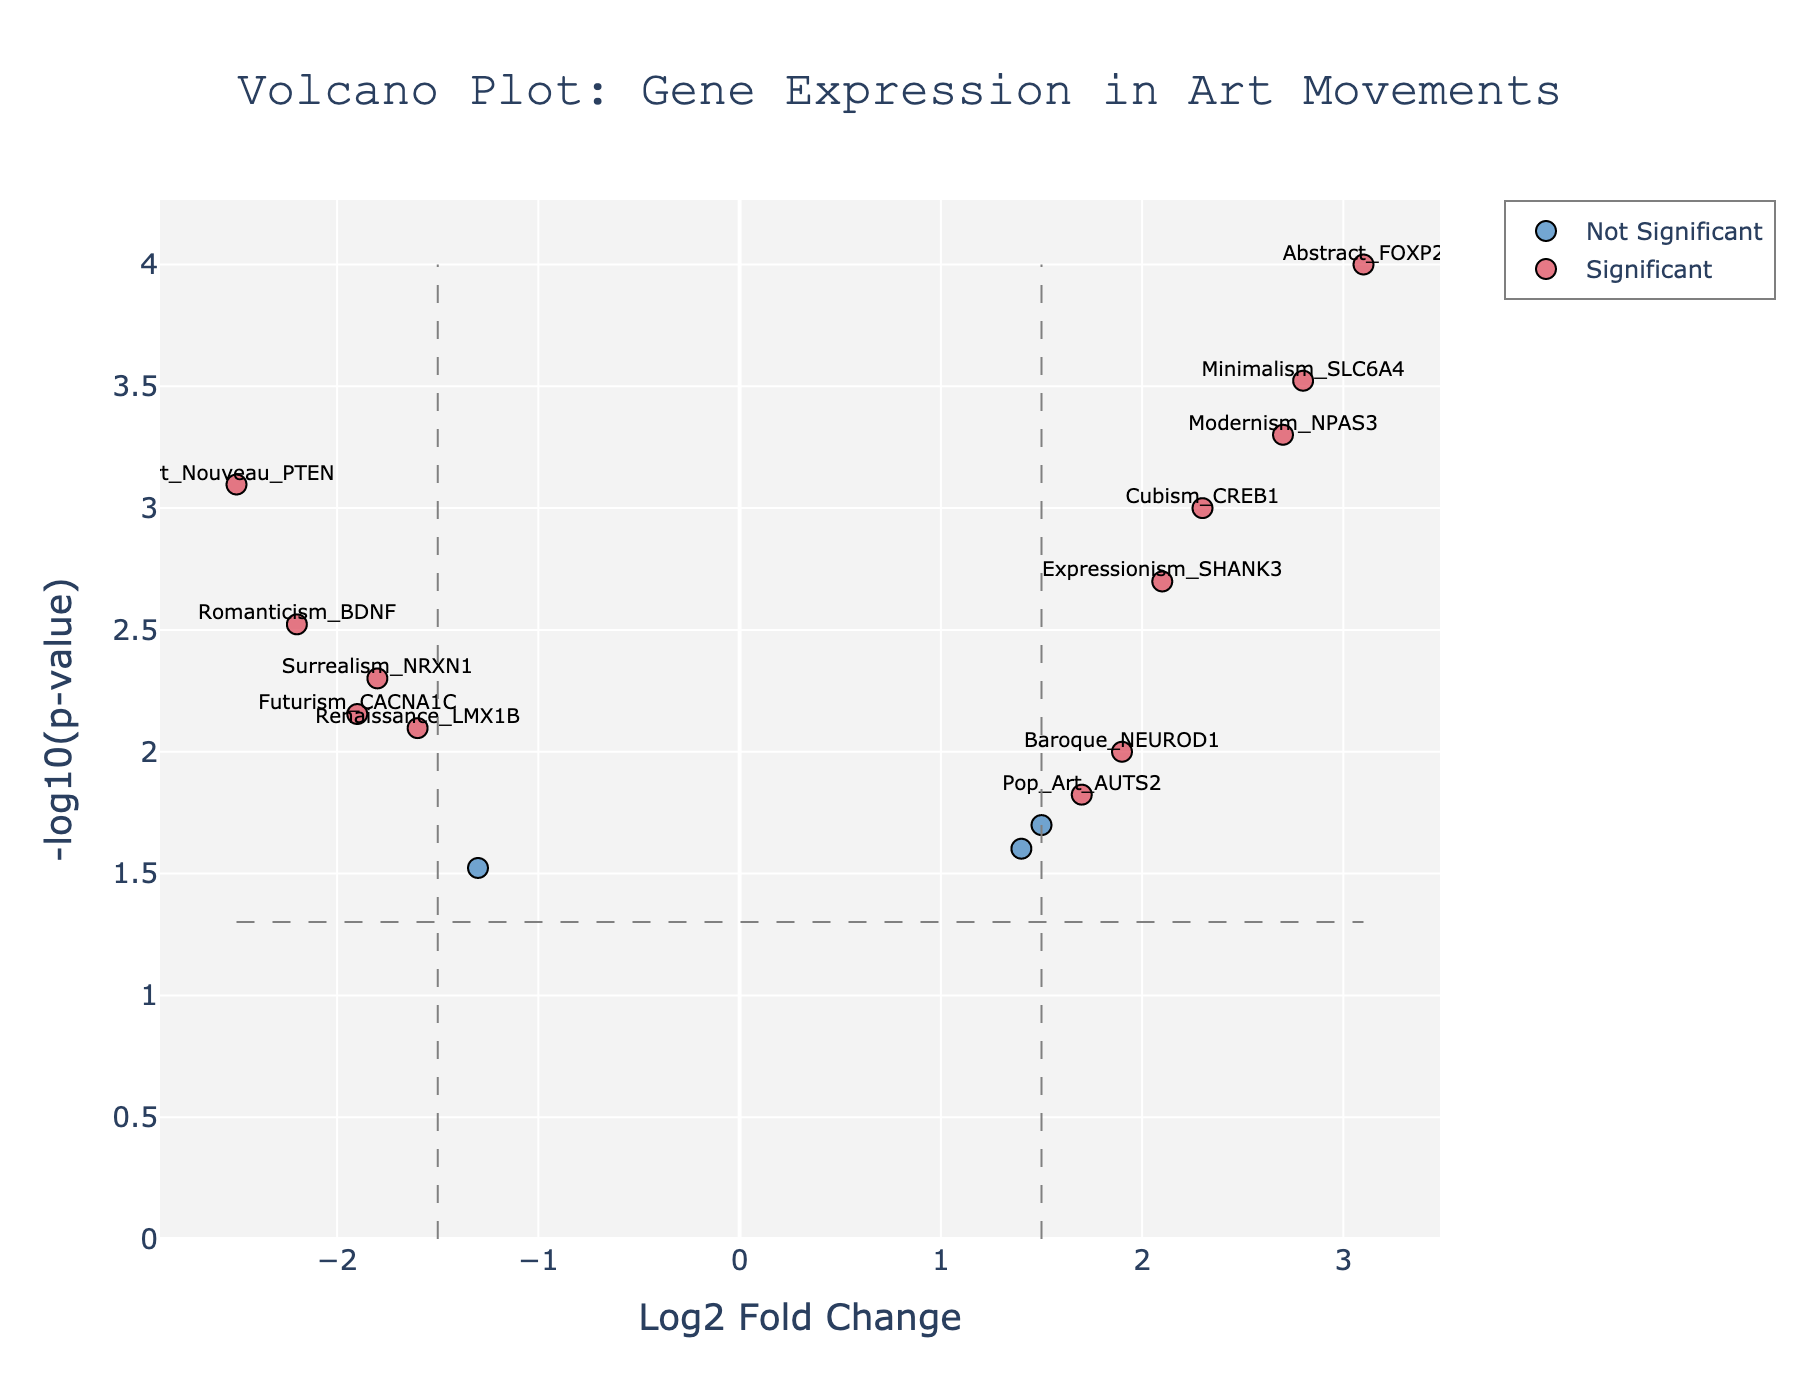What is the title of the plot? The title is usually located at the top of the plot and is clearly labeled to indicate the topic of the plot. In this case, it reads "Volcano Plot: Gene Expression in Art Movements".
Answer: Volcano Plot: Gene Expression in Art Movements What are the labels of the x and y axes? Axes labels are typically positioned along the respective axes. Here, the x-axis is labeled "Log2 Fold Change" and the y-axis is labeled "-log10(p-value)".
Answer: Log2 Fold Change and -log10(p-value) How many genes are marked as significant in the plot? Significant genes are usually indicated by a different color in a volcano plot. In this plot, the significant genes are colored in a distinct hue compared to other data points. We can count the number of marked significant genes.
Answer: 10 Which gene has the highest upregulated fold change? To find the highest upregulated fold change, we look at the point furthest to the right on the x-axis (most positive Log2 Fold Change). Based on the hover text or labels, the gene is identified.
Answer: Abstract_FOXP2 Which gene has the highest downregulated fold change? The highest downregulated fold change is indicated by the point furthest to the left on the x-axis (most negative Log2 Fold Change). The gene can be identified from the hover text or labels.
Answer: Art_Nouveau_PTEN What is the p-value threshold used in the plot? The p-value threshold is indicated by a horizontal line on the plot, often set at a specific p-value level such as 0.05. We find the y-axis value where this line exists and convert it back from -log10(p-value) to p-value.
Answer: 0.05 How many genes have a Log2 Fold Change greater than 2? We find the data points to the right of the vertical reference line set at Log2 Fold Change = 2. Counting these tells us the number of genes meeting this criterion.
Answer: 3 Is there a notable trend or pattern in the gene expression changes among different art movements? Observing the distribution of points, especially those marked as significant, can indicate if certain art movements have similar gene expression changes (e.g., most points clustered in one quadrant).
Answer: Various art movements show diverse gene expression changes with some being significantly upregulated or downregulated What gene has the smallest p-value and what movement is it associated with? The smallest p-value will correspond to the highest -log10(p-value) on the y-axis. By checking the label or hover text at this point, we can identify the gene and its associated movement.
Answer: Abstract_FOXP2 Which genes are labeled on the plot and are considered significant? Significant genes are labeled with their names on the plot. By looking around the labeled data points, we can list these genes.
Answer: Cubism_CREB1, Surrealism_NRXN1, Abstract_FOXP2, Romanticism_BDNF, Baroque_NEUROD1, Renaissance_LMX1B, Modernism_NPAS3, Expressionism_SHANK3, Art_Nouveau_PTEN, Minimalism_SLC6A4 